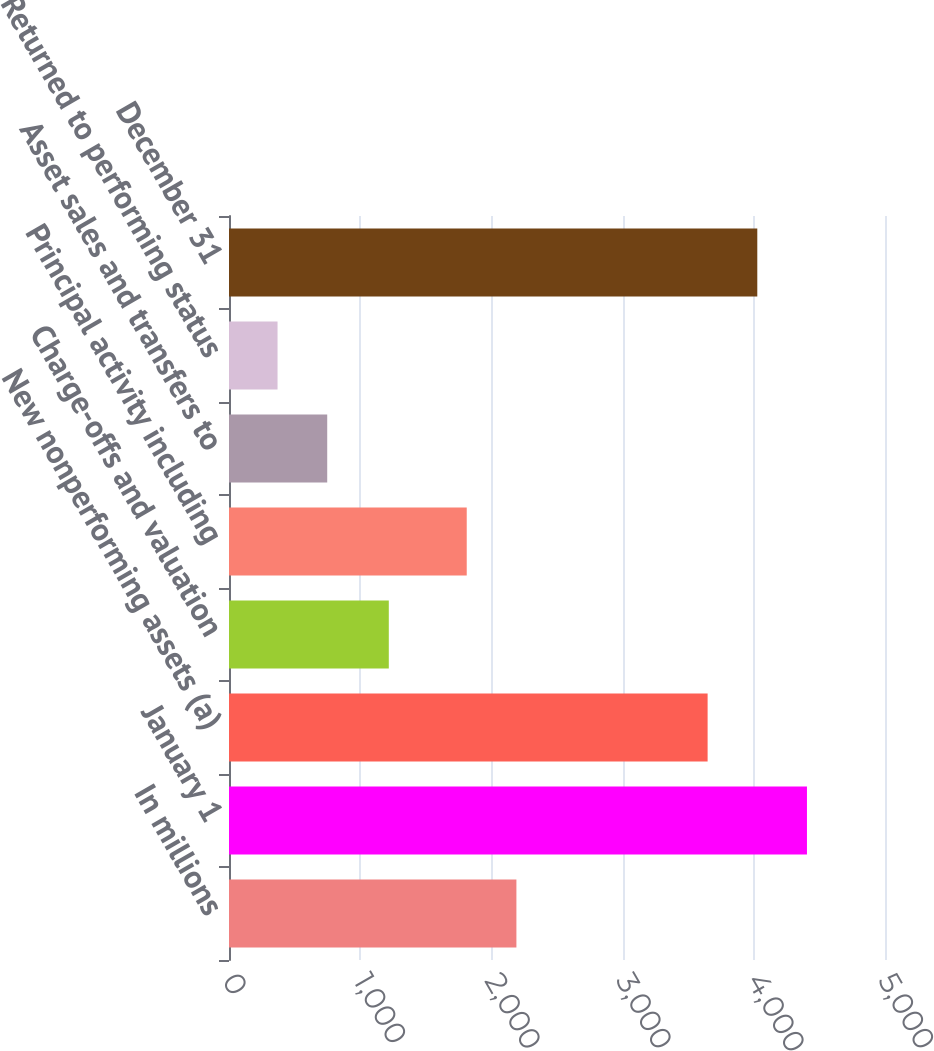<chart> <loc_0><loc_0><loc_500><loc_500><bar_chart><fcel>In millions<fcel>January 1<fcel>New nonperforming assets (a)<fcel>Charge-offs and valuation<fcel>Principal activity including<fcel>Asset sales and transfers to<fcel>Returned to performing status<fcel>December 31<nl><fcel>2190.6<fcel>4405.2<fcel>3648<fcel>1218<fcel>1812<fcel>748.6<fcel>370<fcel>4026.6<nl></chart> 